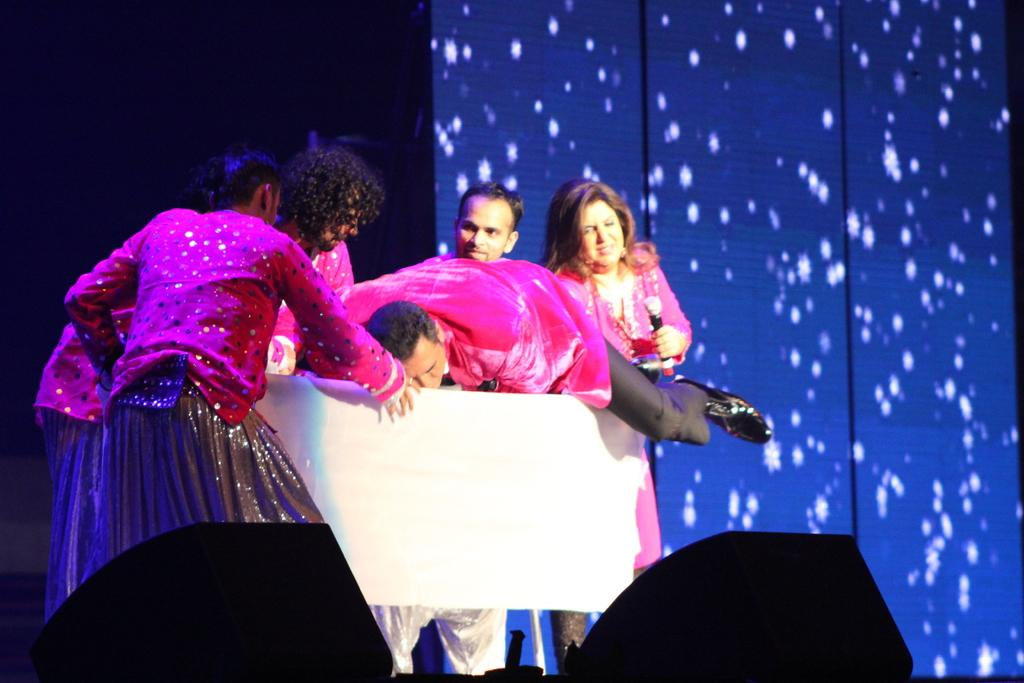Who or what is present in the image? There are people in the image. What are the people wearing? The people are wearing costumes. What object can be seen in the image that resembles a wooden table? There is an object that resembles a wooden table in the image. What color is the background of the image? The background of the image is blue. What type of pot can be seen in the image? There is no pot present in the image; it features people wearing costumes and an object that resembles a wooden table. What time of day is it in the image? The provided facts do not mention the time of day, so it cannot be determined from the image. 